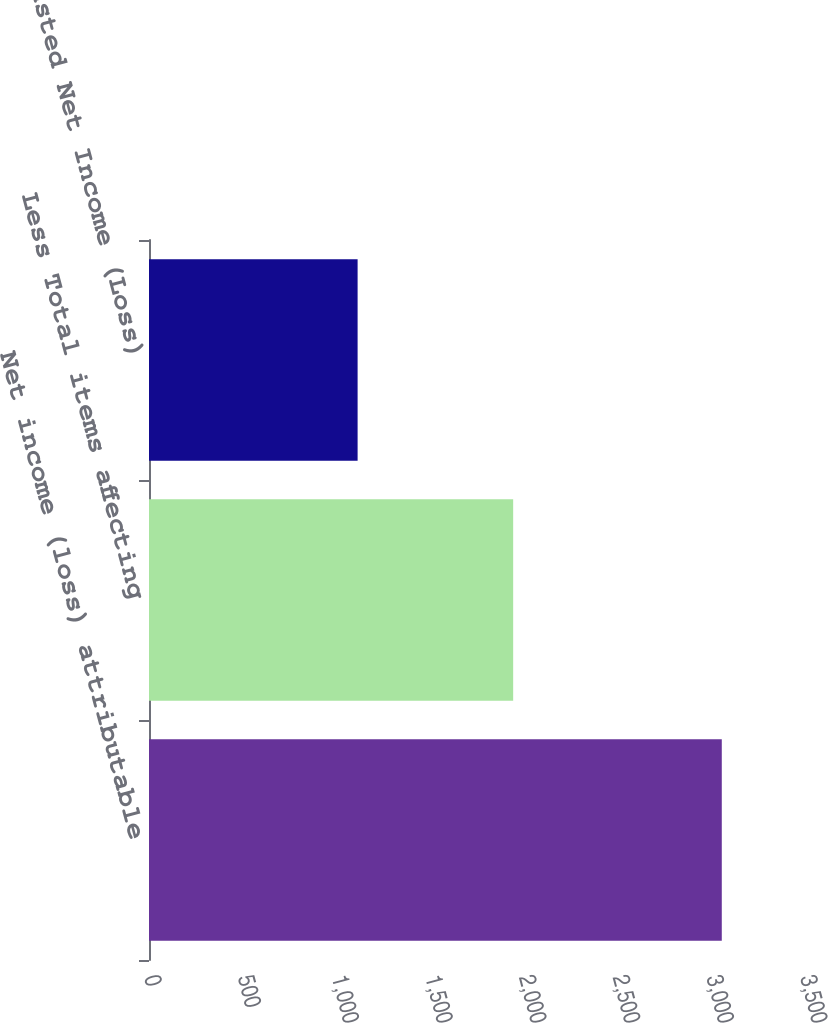<chart> <loc_0><loc_0><loc_500><loc_500><bar_chart><fcel>Net income (loss) attributable<fcel>Less Total items affecting<fcel>Adjusted Net Income (Loss)<nl><fcel>3056<fcel>1943<fcel>1113<nl></chart> 